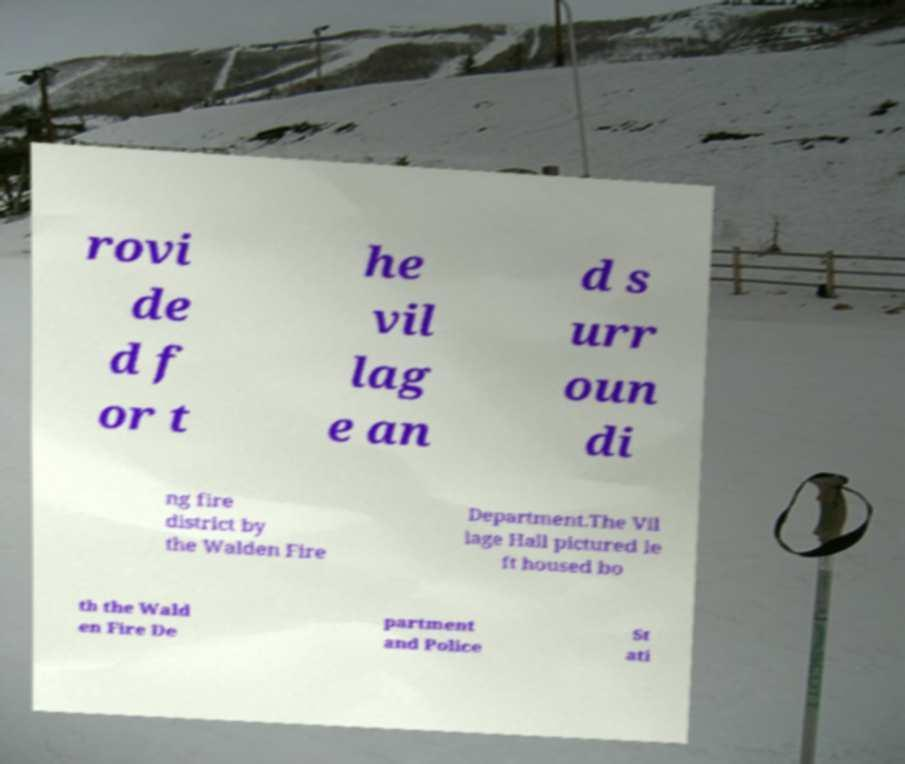Please identify and transcribe the text found in this image. rovi de d f or t he vil lag e an d s urr oun di ng fire district by the Walden Fire Department.The Vil lage Hall pictured le ft housed bo th the Wald en Fire De partment and Police St ati 